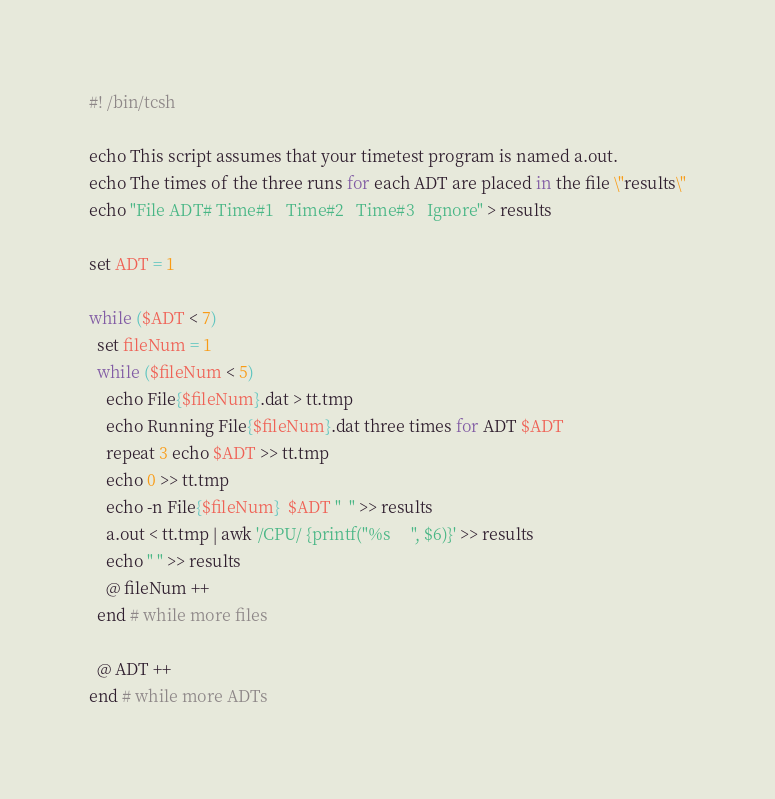Convert code to text. <code><loc_0><loc_0><loc_500><loc_500><_Bash_>#! /bin/tcsh

echo This script assumes that your timetest program is named a.out.
echo The times of the three runs for each ADT are placed in the file \"results\"
echo "File ADT# Time#1   Time#2   Time#3   Ignore" > results

set ADT = 1

while ($ADT < 7)
  set fileNum = 1
  while ($fileNum < 5)
    echo File{$fileNum}.dat > tt.tmp
    echo Running File{$fileNum}.dat three times for ADT $ADT
    repeat 3 echo $ADT >> tt.tmp
    echo 0 >> tt.tmp
    echo -n File{$fileNum}  $ADT "  " >> results 
    a.out < tt.tmp | awk '/CPU/ {printf("%s     ", $6)}' >> results
    echo " " >> results
    @ fileNum ++
  end # while more files

  @ ADT ++
end # while more ADTs
</code> 